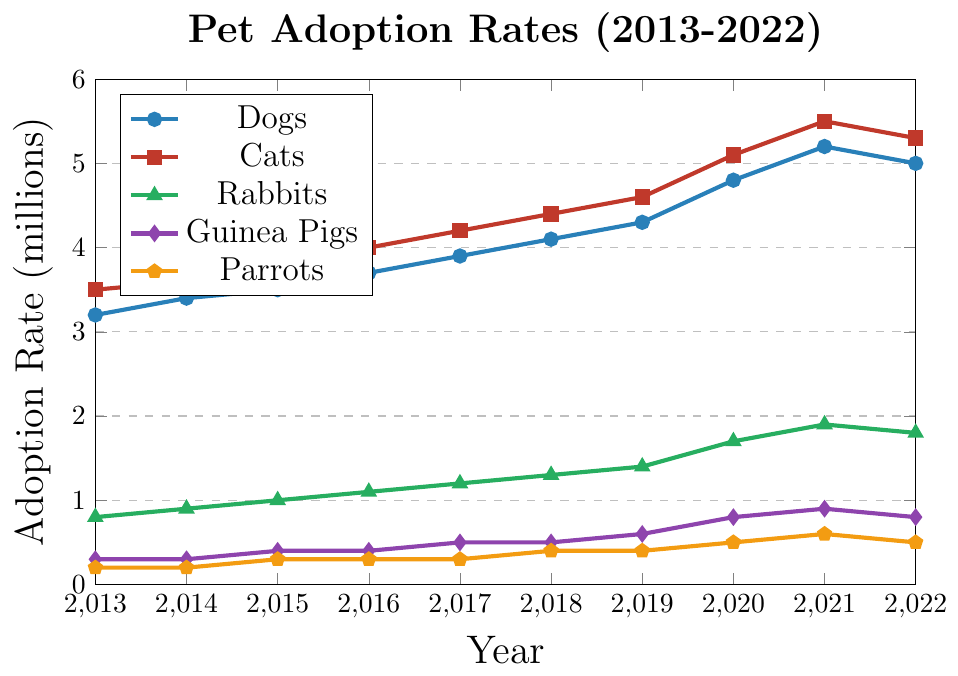What trend is observed in dog adoption rates from 2013 to 2022? The dog adoption rates show a steady increase from 3.2 million in 2013 to a peak of 5.2 million in 2021, followed by a slight decline to 5.0 million in 2022.
Answer: Steady increase with a slight decline at the end During which year did cat adoptions reach their peak? By examining the cat adoption line, the highest point occurs at the year 2021, where the rate is 5.5 million.
Answer: 2021 How do rabbit adoption rates in 2013 compare to 2022? The rabbit adoption rate in 2013 was 0.8 million and increased steadily to 1.8 million in 2022.
Answer: Increased What is the difference in adoption rates between cats and dogs in 2020? The adoption rate for cats in 2020 was 5.1 million, and for dogs, it was 4.8 million. The difference is 5.1 - 4.8 = 0.3 million.
Answer: 0.3 million What visual cue helps distinguish the rabbit adoption rates from other species? The rabbit adoption rates are marked by green triangles, making them visually distinct from the marks used for other species.
Answer: Green triangles Which species saw the highest overall increase in adoption rates from 2013 to 2021? By comparing the adoption rates from 2013 to 2021, dogs increased from 3.2 million to 5.2 million, a total increase of 2.0 million. Cats increased from 3.5 million to 5.5 million, a total increase of 2.0 million as well. Other species had smaller increases.
Answer: Cats and Dogs Which two species had the same adoption rate in 2014? Looking at the 2014 data, dogs had an adoption rate of 3.4 million and cats had 3.6 million, while rabbits had 0.9 million. Both guinea pigs and parrots had the same rate of 0.2 million.
Answer: Guinea Pigs and Parrots 